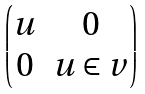<formula> <loc_0><loc_0><loc_500><loc_500>\begin{pmatrix} u & 0 \\ 0 & u \in v \end{pmatrix}</formula> 